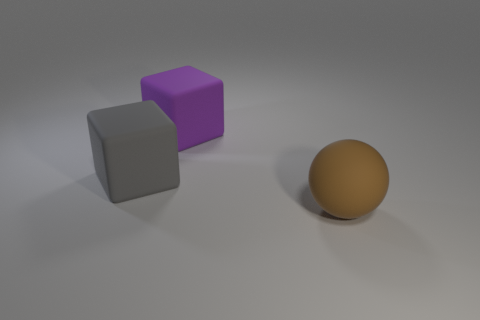Add 1 big brown things. How many objects exist? 4 Subtract all yellow metal balls. Subtract all large purple matte objects. How many objects are left? 2 Add 1 rubber objects. How many rubber objects are left? 4 Add 1 gray objects. How many gray objects exist? 2 Subtract 0 green blocks. How many objects are left? 3 Subtract all balls. How many objects are left? 2 